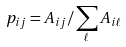Convert formula to latex. <formula><loc_0><loc_0><loc_500><loc_500>p _ { i j } = A _ { i j } / \sum _ { \ell } A _ { i \ell } \,</formula> 